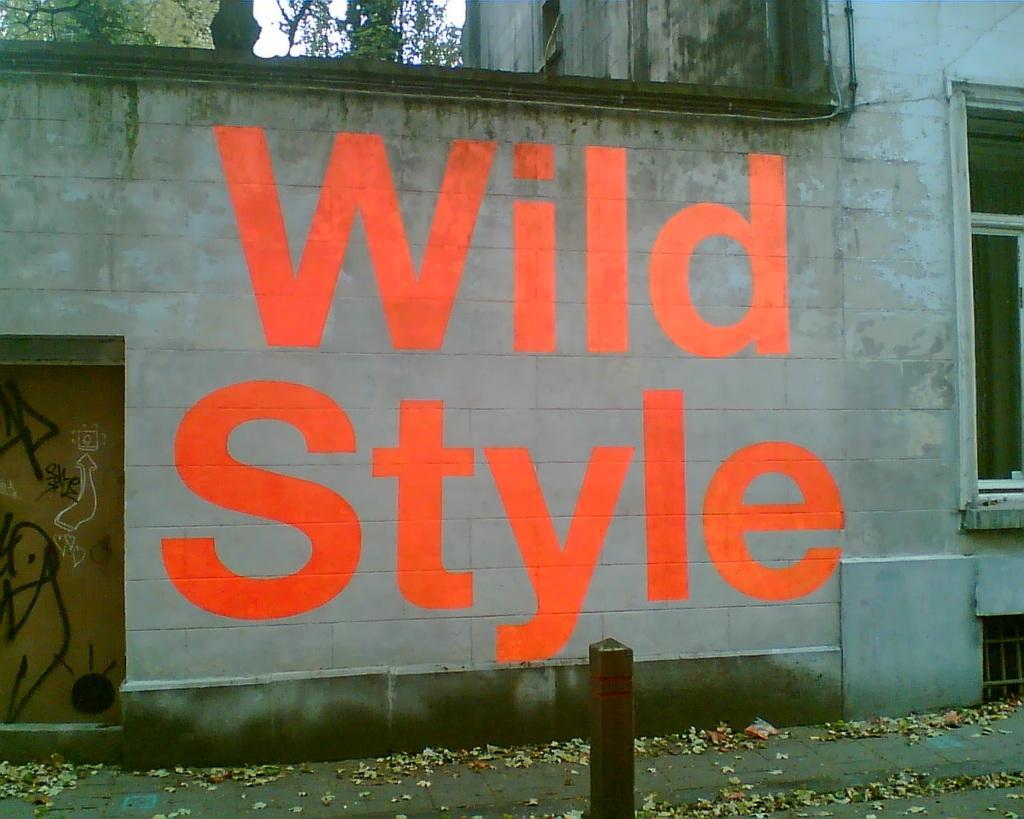Could you give a brief overview of what you see in this image? In this image I can see something written on the wall of a building. There is a door on the left. There is a window on the right. There are trees at the back. 